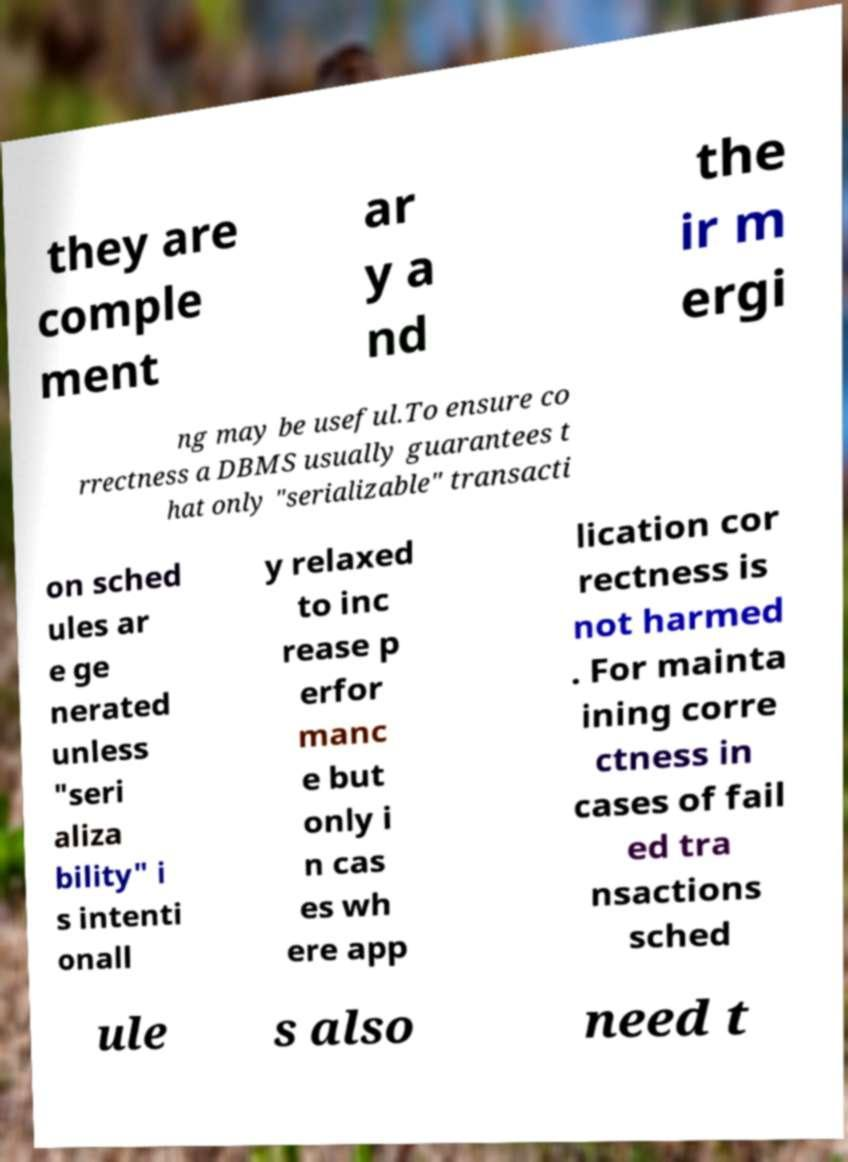I need the written content from this picture converted into text. Can you do that? they are comple ment ar y a nd the ir m ergi ng may be useful.To ensure co rrectness a DBMS usually guarantees t hat only "serializable" transacti on sched ules ar e ge nerated unless "seri aliza bility" i s intenti onall y relaxed to inc rease p erfor manc e but only i n cas es wh ere app lication cor rectness is not harmed . For mainta ining corre ctness in cases of fail ed tra nsactions sched ule s also need t 